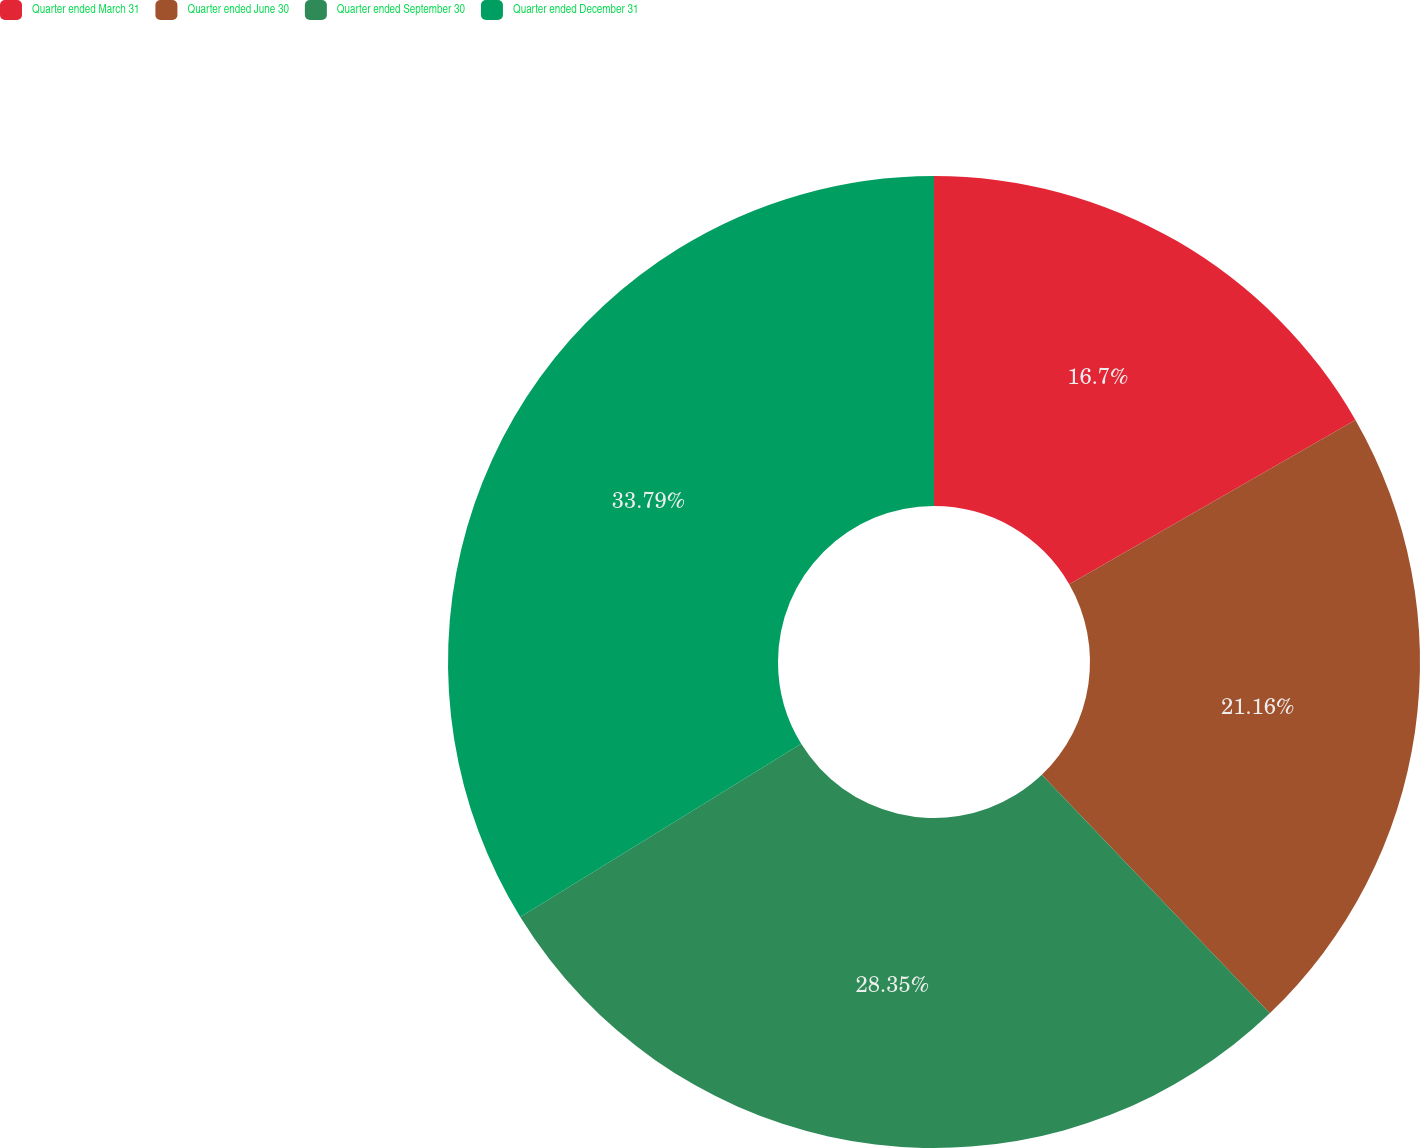<chart> <loc_0><loc_0><loc_500><loc_500><pie_chart><fcel>Quarter ended March 31<fcel>Quarter ended June 30<fcel>Quarter ended September 30<fcel>Quarter ended December 31<nl><fcel>16.7%<fcel>21.16%<fcel>28.35%<fcel>33.79%<nl></chart> 